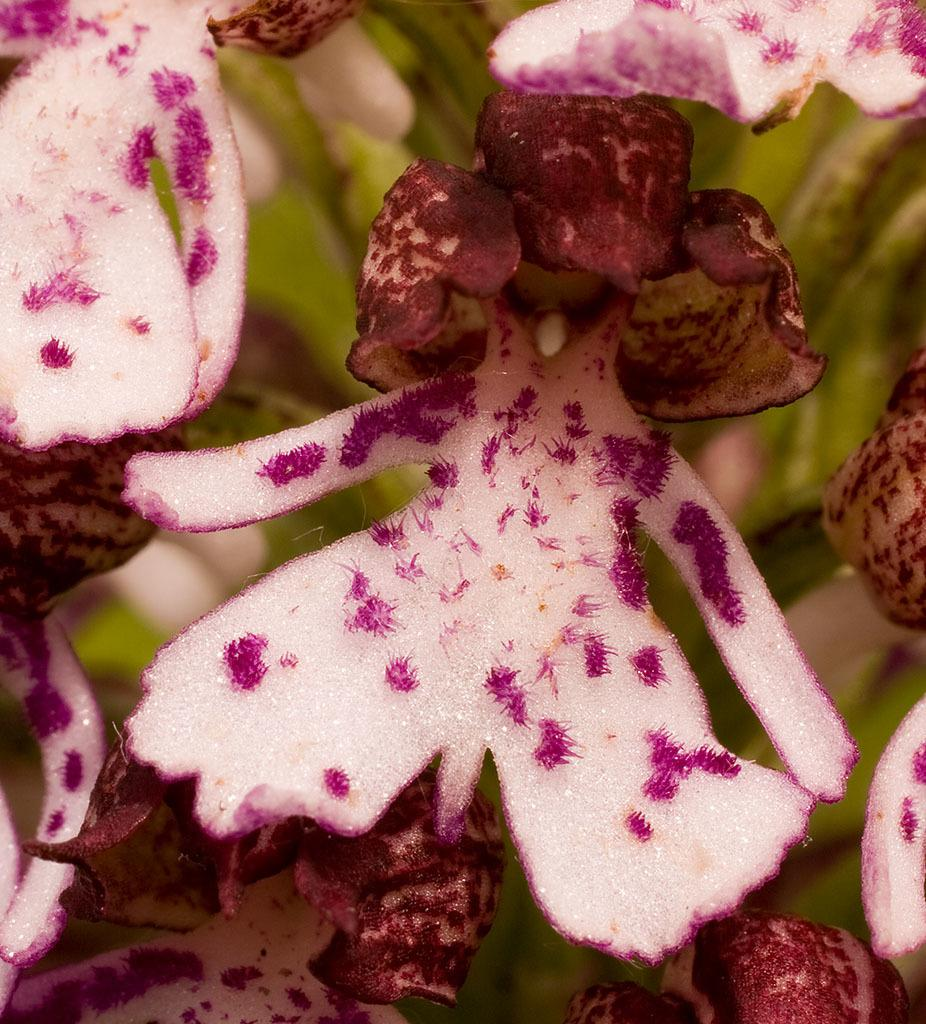What is the main subject of the image? The main subject of the image is many flowers. Can you describe the location of the flowers in the image? The flowers are in the center of the image. How does the number of flowers increase over time in the image? The image is a still image, so there is no change in the number of flowers over time. 